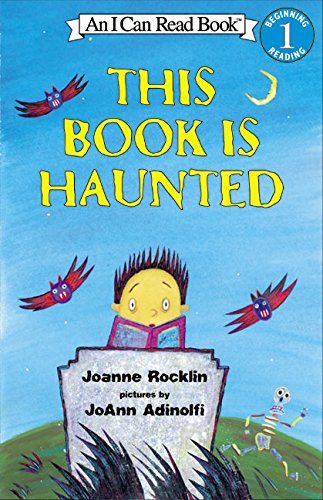What age group is this book aimed at? This book is aimed at early readers, typically between the ages of 4 to 8 years old, designed to support them as they develop their reading skills. What themes might young readers learn from this book? Young readers might learn themes of bravery and curiosity as they explore the imaginative and slightly spooky stories within 'This Book is Haunted', designed to entertain while sparking a love of reading. 